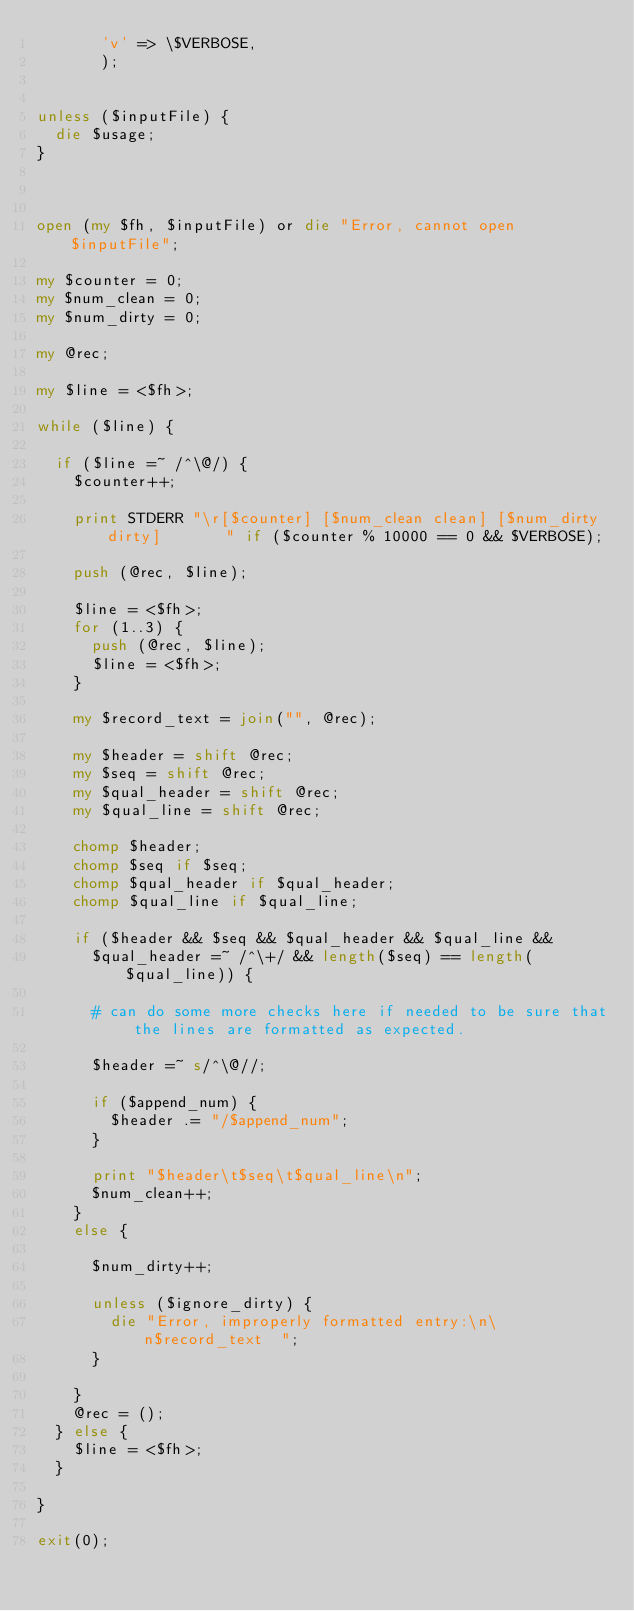Convert code to text. <code><loc_0><loc_0><loc_500><loc_500><_Perl_>			 'v' => \$VERBOSE,
			 );


unless ($inputFile) {
	die $usage;
}



open (my $fh, $inputFile) or die "Error, cannot open $inputFile";

my $counter = 0;
my $num_clean = 0;
my $num_dirty = 0;

my @rec;

my $line = <$fh>;

while ($line) {

	if ($line =~ /^\@/) {
		$counter++;
		
		print STDERR "\r[$counter] [$num_clean clean] [$num_dirty dirty]       " if ($counter % 10000 == 0 && $VERBOSE);
		
		push (@rec, $line);
		
		$line = <$fh>;
		for (1..3) {
			push (@rec, $line);
			$line = <$fh>;
		}
		
		my $record_text = join("", @rec);

		my $header = shift @rec;
		my $seq = shift @rec;
		my $qual_header = shift @rec;
		my $qual_line = shift @rec;
				
		chomp $header;
		chomp $seq if $seq;
		chomp $qual_header if $qual_header;
		chomp $qual_line if $qual_line;
		
		if ($header && $seq && $qual_header && $qual_line && 
			$qual_header =~ /^\+/ && length($seq) == length($qual_line)) {
			
			# can do some more checks here if needed to be sure that the lines are formatted as expected.

			$header =~ s/^\@//;
			
			if ($append_num) {
				$header .= "/$append_num";
			}

			print "$header\t$seq\t$qual_line\n";
			$num_clean++;
		}
		else {

			$num_dirty++;

			unless ($ignore_dirty) {
				die "Error, improperly formatted entry:\n\n$record_text  ";
			}
			
		}
		@rec = ();
	} else {
		$line = <$fh>;
	}
	
}

exit(0);


		
		
		
		
</code> 